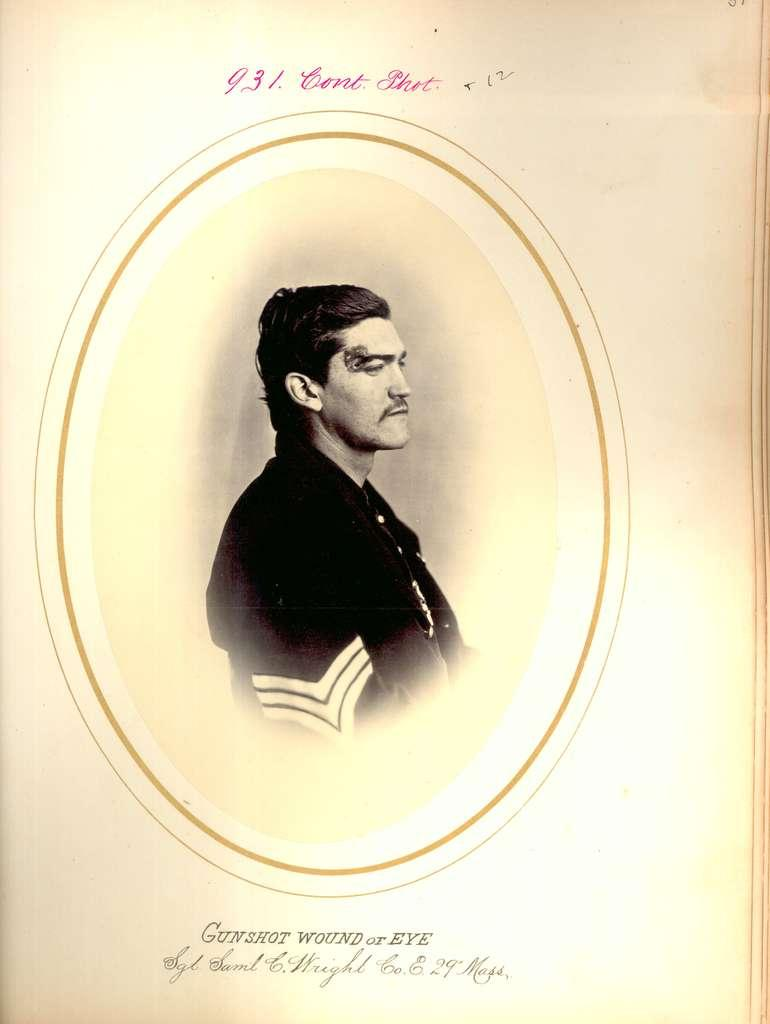What object is present in the image? There is a book in the image. What is depicted on the book? The book has a photo of a man on it. Are there any words or letters on the book? Yes, there is text on the book. What type of crate is being played by the man in the photo on the book? There is no crate or guitar present in the image, and the man in the photo is not playing any instrument. 